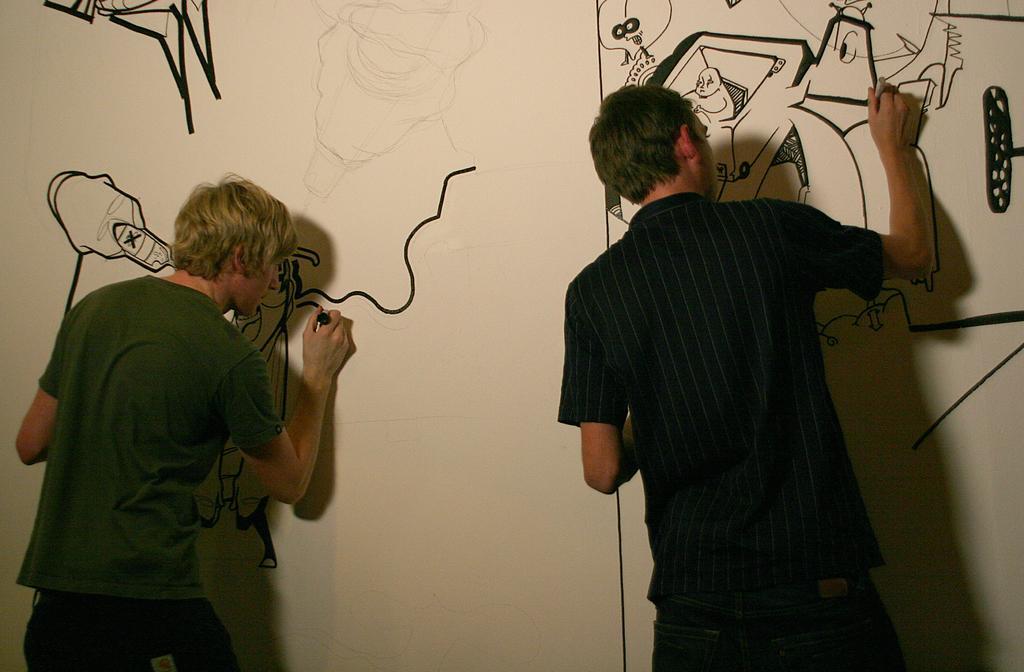Please provide a concise description of this image. In this image we can see two persons drawing sketches on the wall. 